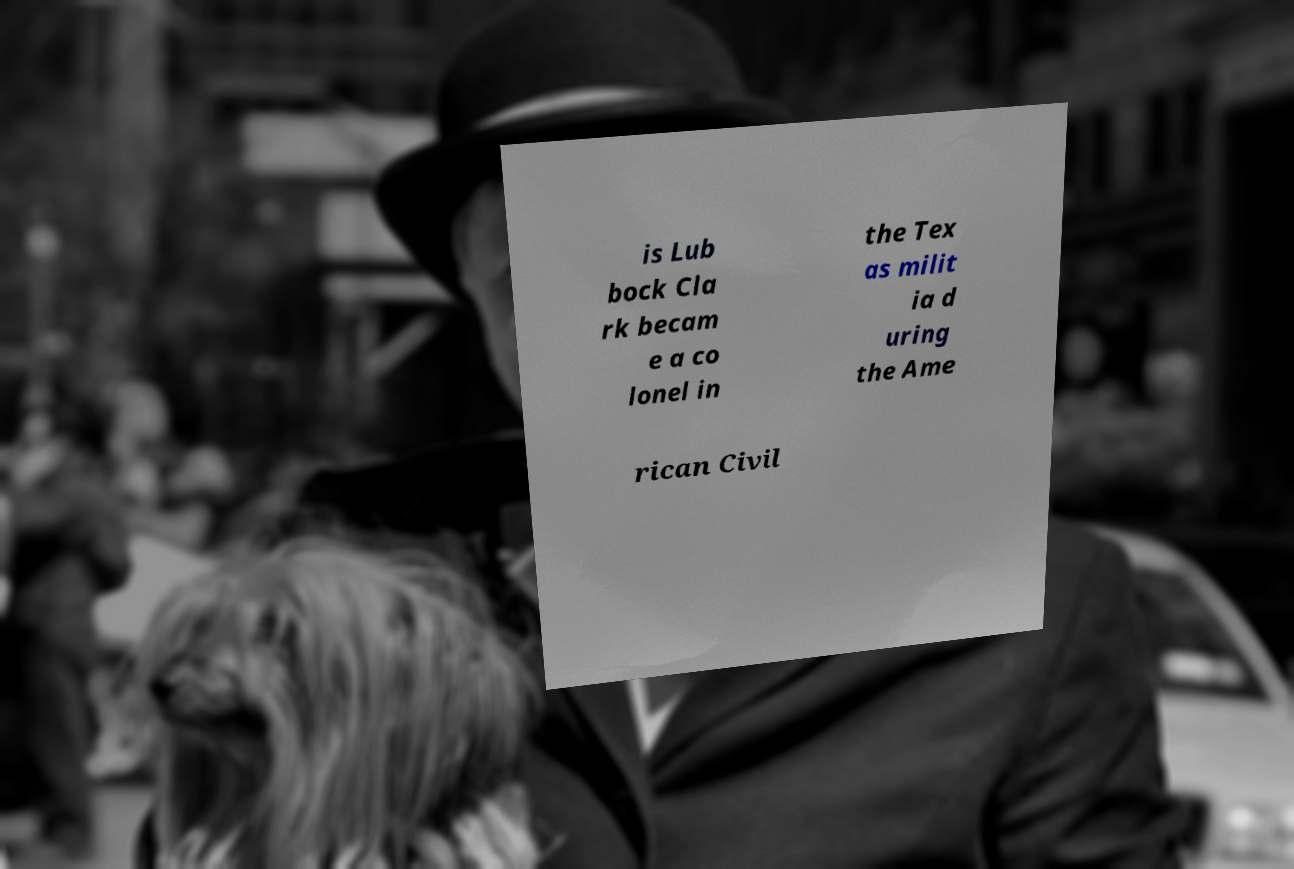There's text embedded in this image that I need extracted. Can you transcribe it verbatim? is Lub bock Cla rk becam e a co lonel in the Tex as milit ia d uring the Ame rican Civil 